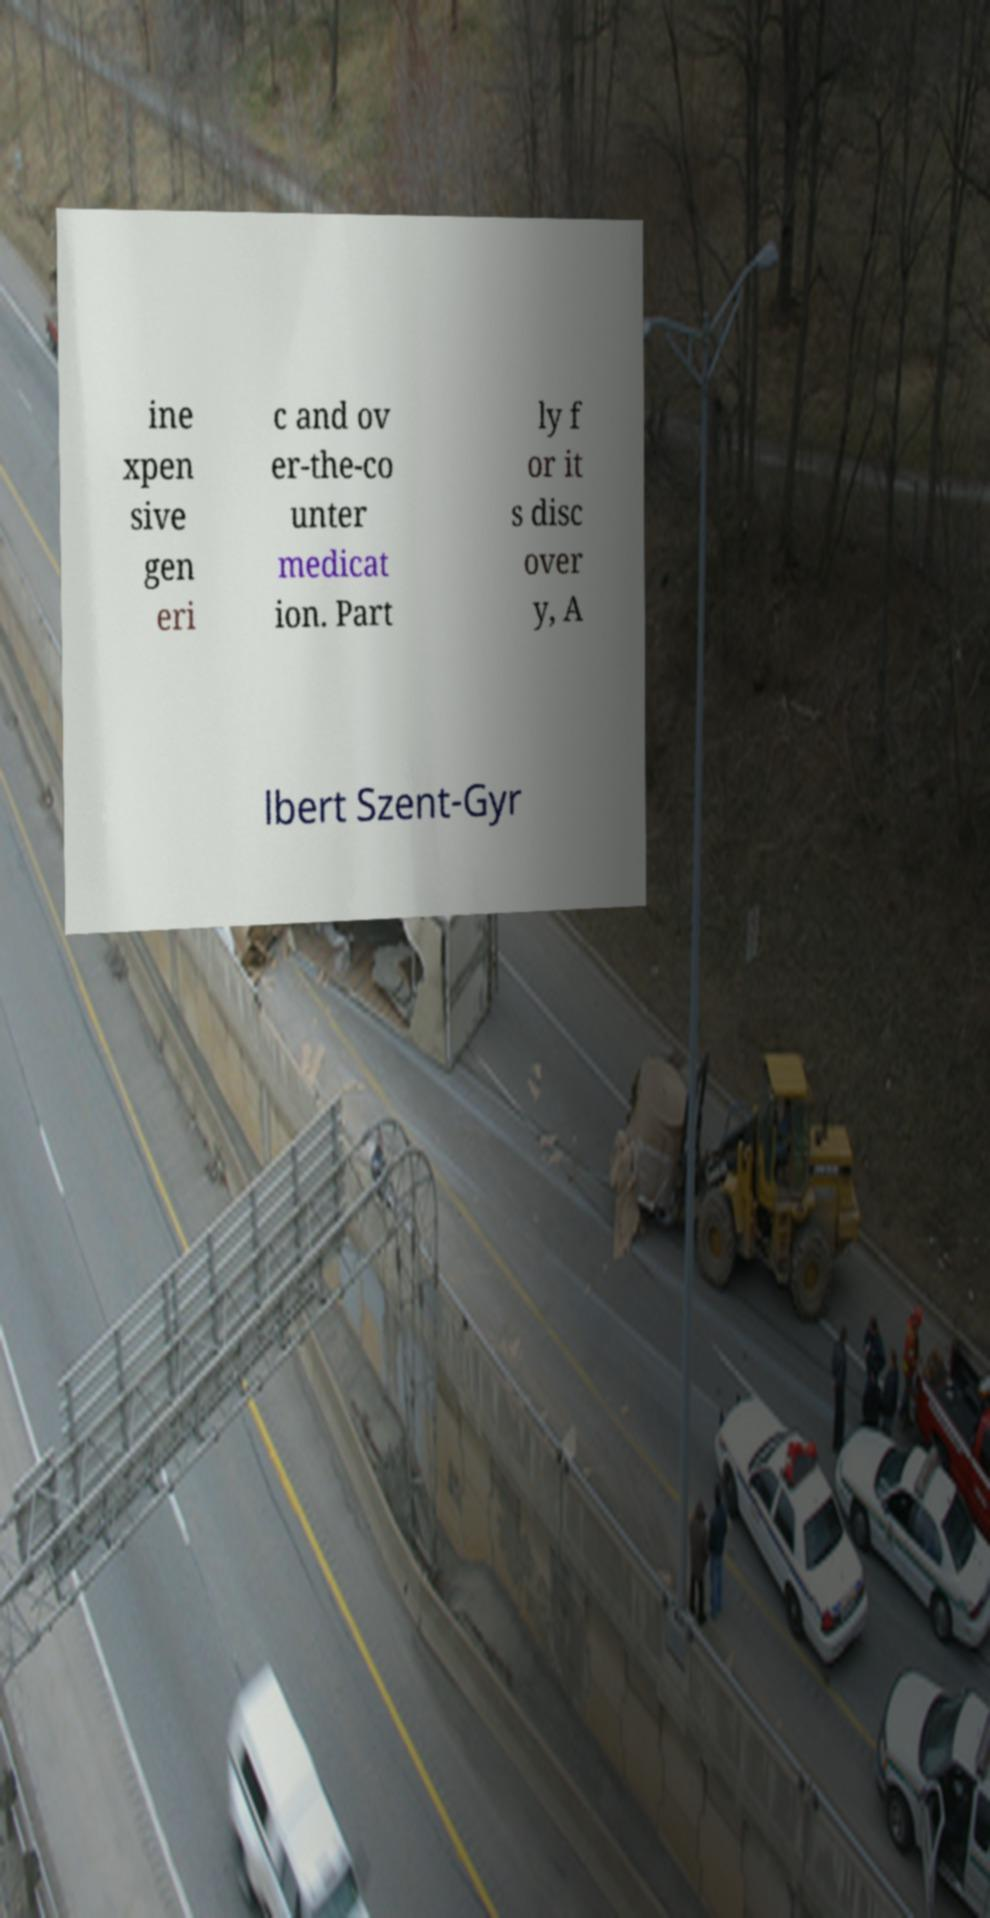Please read and relay the text visible in this image. What does it say? ine xpen sive gen eri c and ov er-the-co unter medicat ion. Part ly f or it s disc over y, A lbert Szent-Gyr 